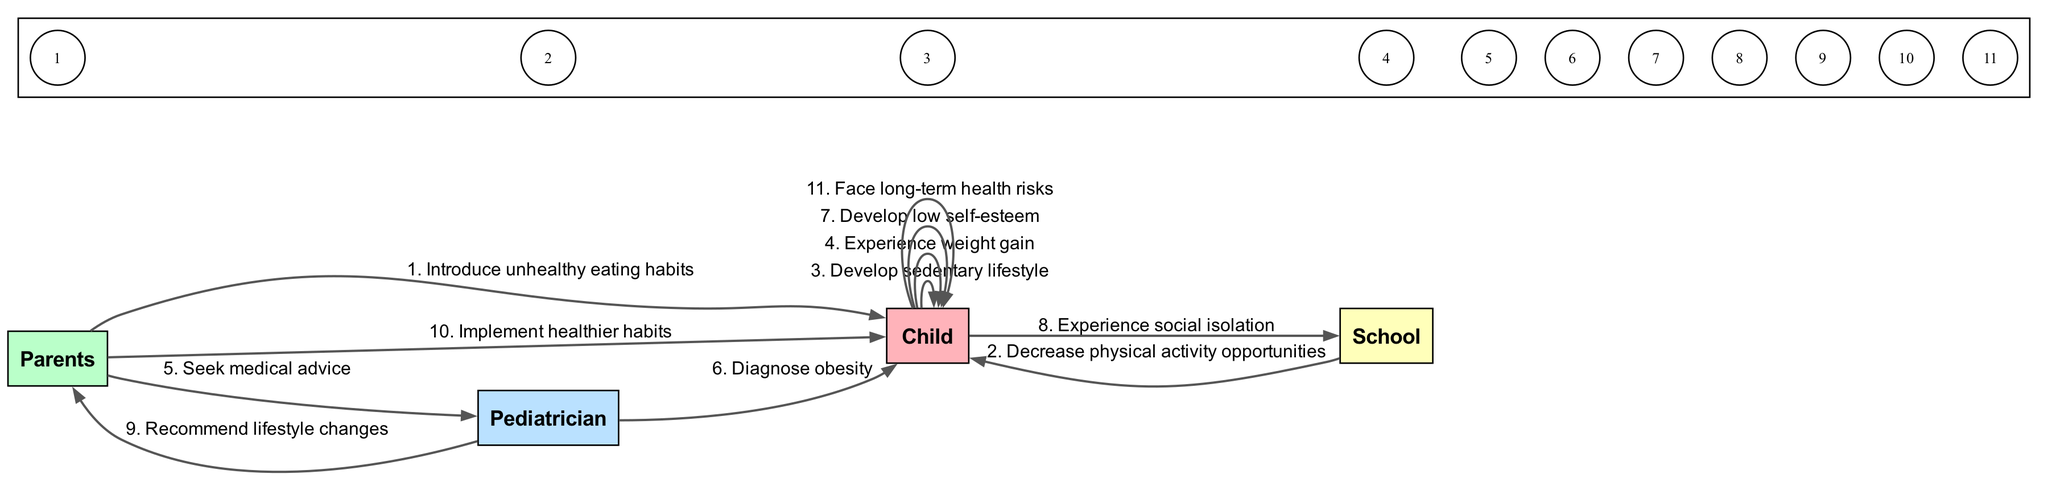What is the first action that leads to the child developing obesity? The first action in the sequence is the parents introducing unhealthy eating habits to the child. This action initiates the process that eventually leads to obesity.
Answer: Introduce unhealthy eating habits How many total actions are listed in the sequence? By counting the actions (edges) described in the sequence, there are ten actions, starting from unhealthy eating habits to facing long-term health risks.
Answer: 10 Which actor diagnoses obesity? According to the sequence of actions, the pediatrician is the actor responsible for diagnosing obesity in the child after the parents seek medical advice.
Answer: Pediatrician What is the consequence of the child experiencing weight gain? Following the action of experiencing weight gain, the child develops low self-esteem, indicating that weight gain has psychological consequences.
Answer: Develop low self-esteem What action follows after the pediatrician recommends lifestyle changes? The action that follows the pediatrician's recommendation is the parents implementing healthier habits for the child, which is a crucial step towards addressing obesity.
Answer: Implement healthier habits How many actors interact with the child during the sequence? The child interacts with three different actors in the sequence: the parents, the pediatrician, and the school. This indicates various influences on the child's obesity development.
Answer: 3 What is the last action that the child faces in the sequence? The last action that appears in the sequence is the child facing long-term health risks as a consequence of developing obesity, which reflects the serious implications of the earlier actions.
Answer: Face long-term health risks How does the school contribute to the child's development of obesity? The school's contribution to the child's obesity is through decreasing opportunities for physical activity, which promotes a sedentary lifestyle that is linked to weight gain.
Answer: Decrease physical activity opportunities What is the implication of the child experiencing social isolation? The implication of experiencing social isolation is a potential exacerbation of low self-esteem and furthering the psychological impact of obesity, demonstrating how social dynamics affect a child's mental health.
Answer: Experience social isolation 